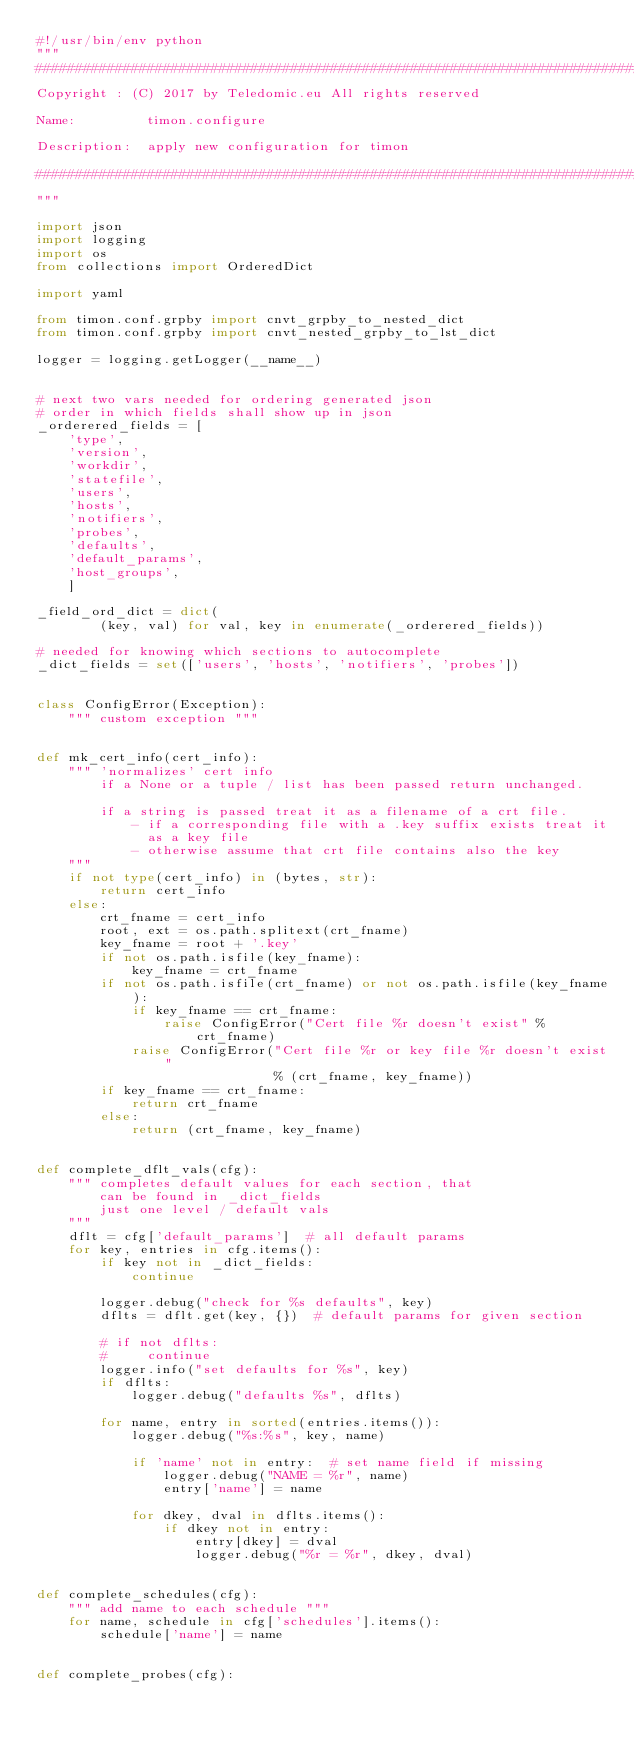Convert code to text. <code><loc_0><loc_0><loc_500><loc_500><_Python_>#!/usr/bin/env python
"""
#############################################################################
Copyright : (C) 2017 by Teledomic.eu All rights reserved

Name:         timon.configure

Description:  apply new configuration for timon

#############################################################################
"""

import json
import logging
import os
from collections import OrderedDict

import yaml

from timon.conf.grpby import cnvt_grpby_to_nested_dict
from timon.conf.grpby import cnvt_nested_grpby_to_lst_dict

logger = logging.getLogger(__name__)


# next two vars needed for ordering generated json
# order in which fields shall show up in json
_orderered_fields = [
    'type',
    'version',
    'workdir',
    'statefile',
    'users',
    'hosts',
    'notifiers',
    'probes',
    'defaults',
    'default_params',
    'host_groups',
    ]

_field_ord_dict = dict(
        (key, val) for val, key in enumerate(_orderered_fields))

# needed for knowing which sections to autocomplete
_dict_fields = set(['users', 'hosts', 'notifiers', 'probes'])


class ConfigError(Exception):
    """ custom exception """


def mk_cert_info(cert_info):
    """ 'normalizes' cert info
        if a None or a tuple / list has been passed return unchanged.

        if a string is passed treat it as a filename of a crt file.
            - if a corresponding file with a .key suffix exists treat it
              as a key file
            - otherwise assume that crt file contains also the key
    """
    if not type(cert_info) in (bytes, str):
        return cert_info
    else:
        crt_fname = cert_info
        root, ext = os.path.splitext(crt_fname)
        key_fname = root + '.key'
        if not os.path.isfile(key_fname):
            key_fname = crt_fname
        if not os.path.isfile(crt_fname) or not os.path.isfile(key_fname):
            if key_fname == crt_fname:
                raise ConfigError("Cert file %r doesn't exist" % crt_fname)
            raise ConfigError("Cert file %r or key file %r doesn't exist"
                              % (crt_fname, key_fname))
        if key_fname == crt_fname:
            return crt_fname
        else:
            return (crt_fname, key_fname)


def complete_dflt_vals(cfg):
    """ completes default values for each section, that
        can be found in _dict_fields
        just one level / default vals
    """
    dflt = cfg['default_params']  # all default params
    for key, entries in cfg.items():
        if key not in _dict_fields:
            continue

        logger.debug("check for %s defaults", key)
        dflts = dflt.get(key, {})  # default params for given section

        # if not dflts:
        #     continue
        logger.info("set defaults for %s", key)
        if dflts:
            logger.debug("defaults %s", dflts)

        for name, entry in sorted(entries.items()):
            logger.debug("%s:%s", key, name)

            if 'name' not in entry:  # set name field if missing
                logger.debug("NAME = %r", name)
                entry['name'] = name

            for dkey, dval in dflts.items():
                if dkey not in entry:
                    entry[dkey] = dval
                    logger.debug("%r = %r", dkey, dval)


def complete_schedules(cfg):
    """ add name to each schedule """
    for name, schedule in cfg['schedules'].items():
        schedule['name'] = name


def complete_probes(cfg):</code> 